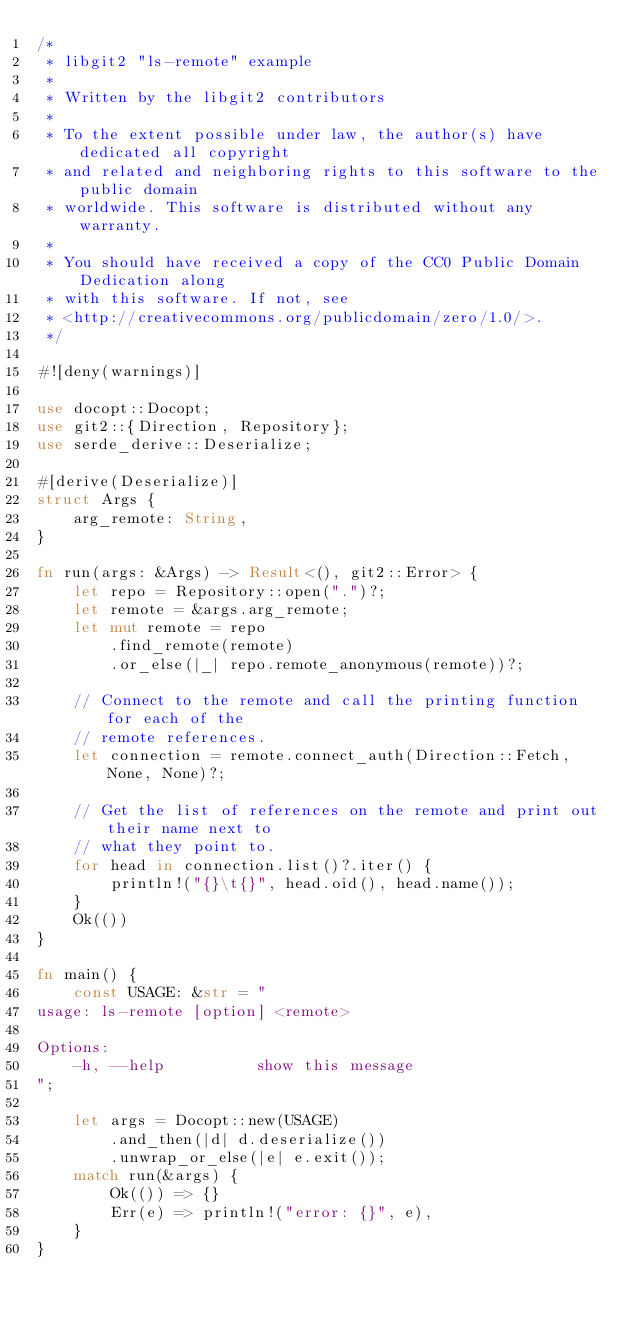<code> <loc_0><loc_0><loc_500><loc_500><_Rust_>/*
 * libgit2 "ls-remote" example
 *
 * Written by the libgit2 contributors
 *
 * To the extent possible under law, the author(s) have dedicated all copyright
 * and related and neighboring rights to this software to the public domain
 * worldwide. This software is distributed without any warranty.
 *
 * You should have received a copy of the CC0 Public Domain Dedication along
 * with this software. If not, see
 * <http://creativecommons.org/publicdomain/zero/1.0/>.
 */

#![deny(warnings)]

use docopt::Docopt;
use git2::{Direction, Repository};
use serde_derive::Deserialize;

#[derive(Deserialize)]
struct Args {
    arg_remote: String,
}

fn run(args: &Args) -> Result<(), git2::Error> {
    let repo = Repository::open(".")?;
    let remote = &args.arg_remote;
    let mut remote = repo
        .find_remote(remote)
        .or_else(|_| repo.remote_anonymous(remote))?;

    // Connect to the remote and call the printing function for each of the
    // remote references.
    let connection = remote.connect_auth(Direction::Fetch, None, None)?;

    // Get the list of references on the remote and print out their name next to
    // what they point to.
    for head in connection.list()?.iter() {
        println!("{}\t{}", head.oid(), head.name());
    }
    Ok(())
}

fn main() {
    const USAGE: &str = "
usage: ls-remote [option] <remote>

Options:
    -h, --help          show this message
";

    let args = Docopt::new(USAGE)
        .and_then(|d| d.deserialize())
        .unwrap_or_else(|e| e.exit());
    match run(&args) {
        Ok(()) => {}
        Err(e) => println!("error: {}", e),
    }
}
</code> 